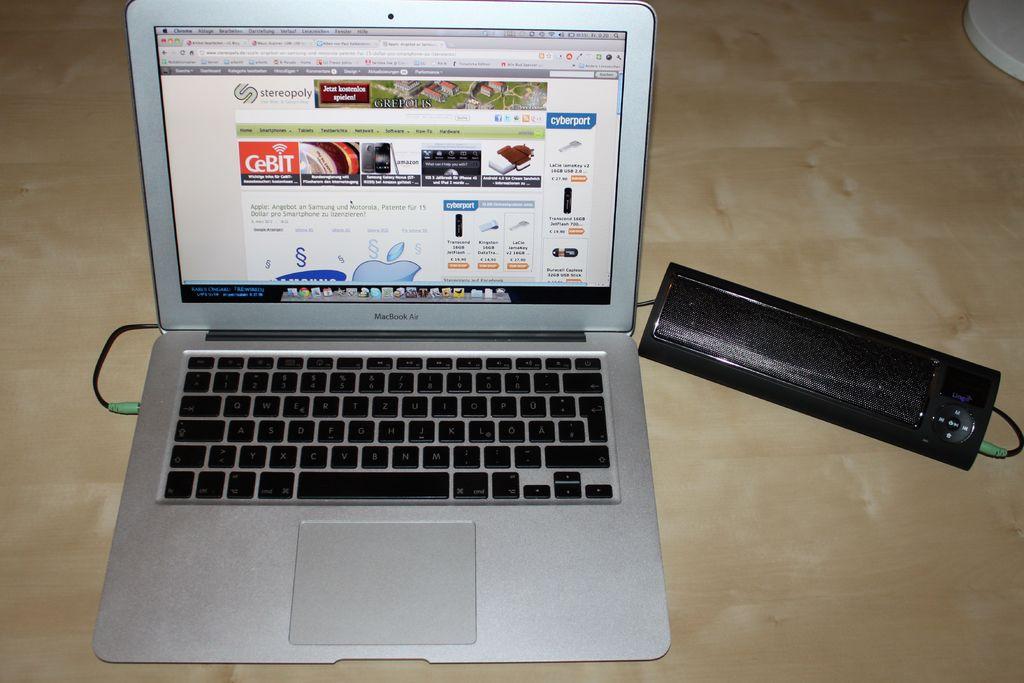What is being advertised on the top right?
Your response must be concise. Cyberport. 